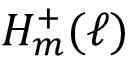Convert formula to latex. <formula><loc_0><loc_0><loc_500><loc_500>H _ { m } ^ { + } ( \ell )</formula> 